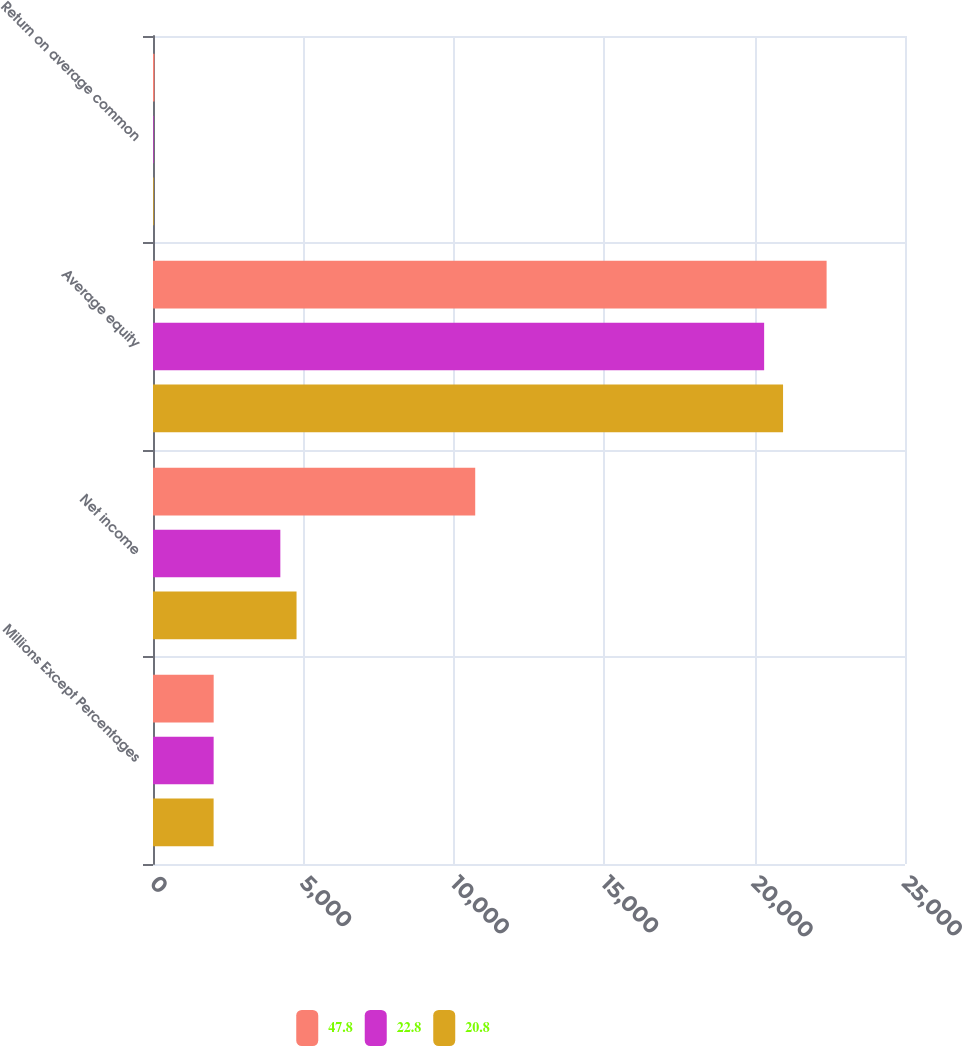Convert chart. <chart><loc_0><loc_0><loc_500><loc_500><stacked_bar_chart><ecel><fcel>Millions Except Percentages<fcel>Net income<fcel>Average equity<fcel>Return on average common<nl><fcel>47.8<fcel>2017<fcel>10712<fcel>22394<fcel>47.8<nl><fcel>22.8<fcel>2016<fcel>4233<fcel>20317<fcel>20.8<nl><fcel>20.8<fcel>2015<fcel>4772<fcel>20946<fcel>22.8<nl></chart> 